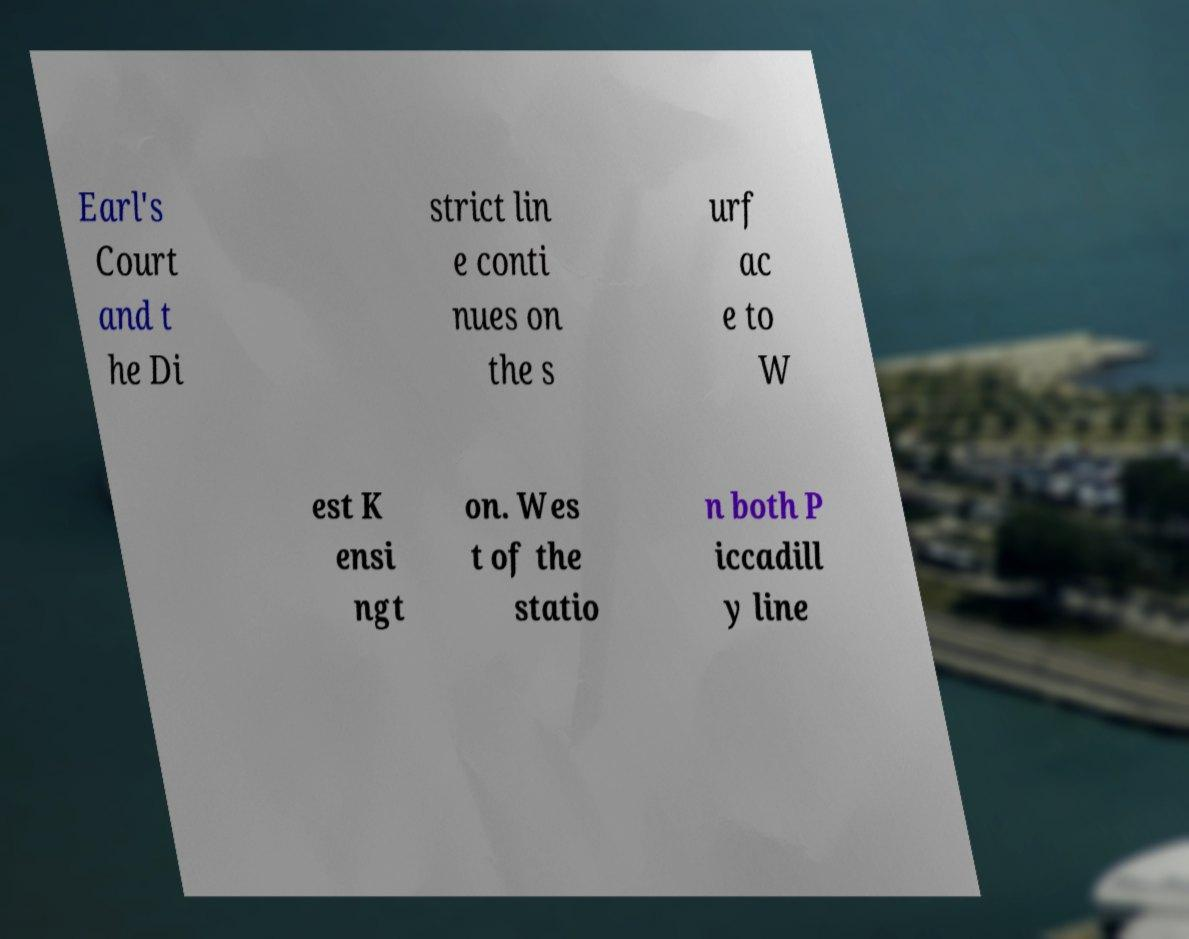There's text embedded in this image that I need extracted. Can you transcribe it verbatim? Earl's Court and t he Di strict lin e conti nues on the s urf ac e to W est K ensi ngt on. Wes t of the statio n both P iccadill y line 